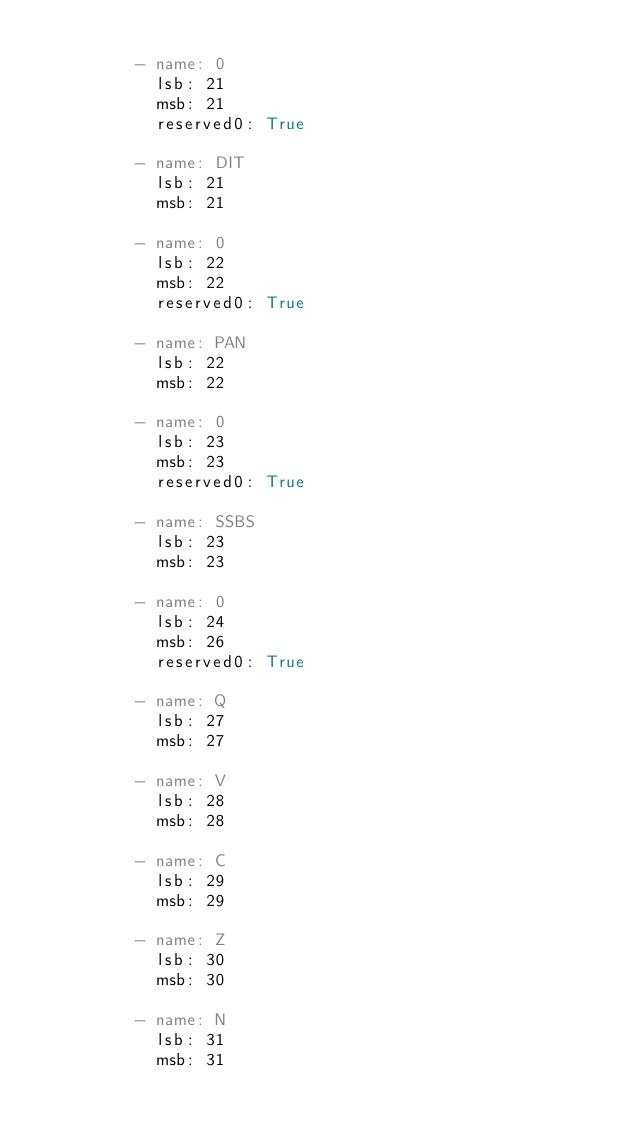Convert code to text. <code><loc_0><loc_0><loc_500><loc_500><_YAML_>
          - name: 0
            lsb: 21
            msb: 21
            reserved0: True

          - name: DIT
            lsb: 21
            msb: 21

          - name: 0
            lsb: 22
            msb: 22
            reserved0: True

          - name: PAN
            lsb: 22
            msb: 22

          - name: 0
            lsb: 23
            msb: 23
            reserved0: True

          - name: SSBS
            lsb: 23
            msb: 23

          - name: 0
            lsb: 24
            msb: 26
            reserved0: True

          - name: Q
            lsb: 27
            msb: 27

          - name: V
            lsb: 28
            msb: 28

          - name: C
            lsb: 29
            msb: 29

          - name: Z
            lsb: 30
            msb: 30

          - name: N
            lsb: 31
            msb: 31
</code> 